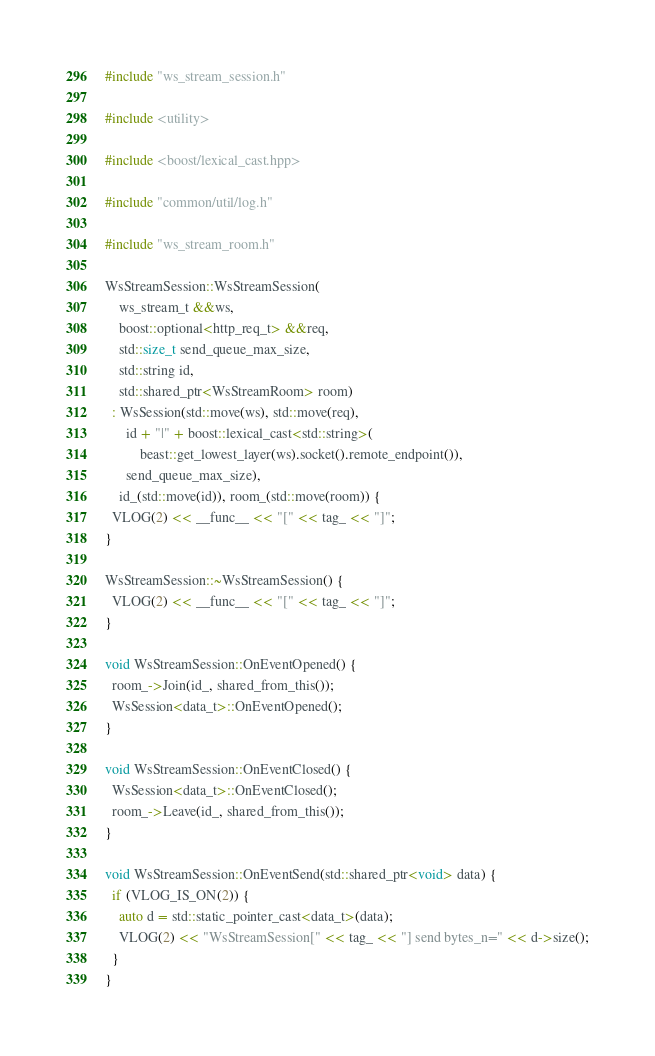<code> <loc_0><loc_0><loc_500><loc_500><_C++_>#include "ws_stream_session.h"

#include <utility>

#include <boost/lexical_cast.hpp>

#include "common/util/log.h"

#include "ws_stream_room.h"

WsStreamSession::WsStreamSession(
    ws_stream_t &&ws,
    boost::optional<http_req_t> &&req,
    std::size_t send_queue_max_size,
    std::string id,
    std::shared_ptr<WsStreamRoom> room)
  : WsSession(std::move(ws), std::move(req),
      id + "|" + boost::lexical_cast<std::string>(
          beast::get_lowest_layer(ws).socket().remote_endpoint()),
      send_queue_max_size),
    id_(std::move(id)), room_(std::move(room)) {
  VLOG(2) << __func__ << "[" << tag_ << "]";
}

WsStreamSession::~WsStreamSession() {
  VLOG(2) << __func__ << "[" << tag_ << "]";
}

void WsStreamSession::OnEventOpened() {
  room_->Join(id_, shared_from_this());
  WsSession<data_t>::OnEventOpened();
}

void WsStreamSession::OnEventClosed() {
  WsSession<data_t>::OnEventClosed();
  room_->Leave(id_, shared_from_this());
}

void WsStreamSession::OnEventSend(std::shared_ptr<void> data) {
  if (VLOG_IS_ON(2)) {
    auto d = std::static_pointer_cast<data_t>(data);
    VLOG(2) << "WsStreamSession[" << tag_ << "] send bytes_n=" << d->size();
  }
}
</code> 